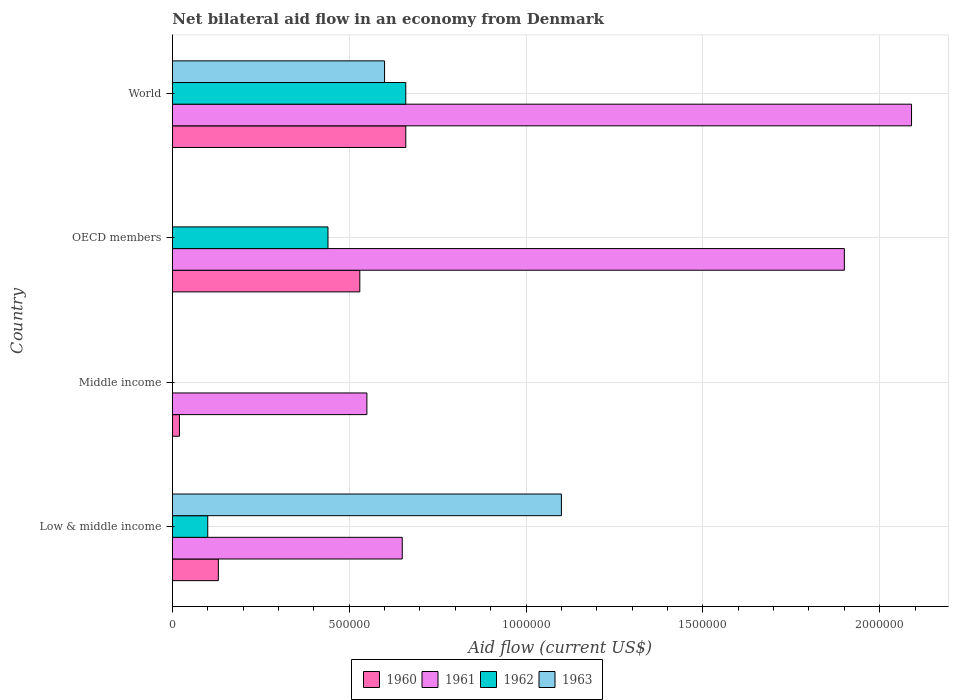Are the number of bars per tick equal to the number of legend labels?
Your answer should be compact. No. Are the number of bars on each tick of the Y-axis equal?
Provide a short and direct response. No. What is the label of the 3rd group of bars from the top?
Your answer should be very brief. Middle income. In how many cases, is the number of bars for a given country not equal to the number of legend labels?
Your answer should be very brief. 2. Across all countries, what is the minimum net bilateral aid flow in 1963?
Your answer should be compact. 0. What is the total net bilateral aid flow in 1963 in the graph?
Give a very brief answer. 1.70e+06. What is the difference between the net bilateral aid flow in 1963 in Middle income and the net bilateral aid flow in 1960 in World?
Give a very brief answer. -6.60e+05. What is the average net bilateral aid flow in 1963 per country?
Provide a succinct answer. 4.25e+05. What is the difference between the net bilateral aid flow in 1962 and net bilateral aid flow in 1961 in World?
Provide a succinct answer. -1.43e+06. In how many countries, is the net bilateral aid flow in 1962 greater than 600000 US$?
Provide a short and direct response. 1. What is the ratio of the net bilateral aid flow in 1960 in Middle income to that in World?
Your answer should be compact. 0.03. Is the difference between the net bilateral aid flow in 1962 in OECD members and World greater than the difference between the net bilateral aid flow in 1961 in OECD members and World?
Offer a terse response. No. What is the difference between the highest and the second highest net bilateral aid flow in 1961?
Keep it short and to the point. 1.90e+05. What is the difference between the highest and the lowest net bilateral aid flow in 1963?
Keep it short and to the point. 1.10e+06. Is the sum of the net bilateral aid flow in 1962 in Low & middle income and OECD members greater than the maximum net bilateral aid flow in 1963 across all countries?
Provide a short and direct response. No. Are all the bars in the graph horizontal?
Keep it short and to the point. Yes. How many countries are there in the graph?
Offer a very short reply. 4. What is the difference between two consecutive major ticks on the X-axis?
Provide a succinct answer. 5.00e+05. Are the values on the major ticks of X-axis written in scientific E-notation?
Provide a succinct answer. No. Does the graph contain any zero values?
Give a very brief answer. Yes. Where does the legend appear in the graph?
Provide a succinct answer. Bottom center. How many legend labels are there?
Make the answer very short. 4. How are the legend labels stacked?
Give a very brief answer. Horizontal. What is the title of the graph?
Your response must be concise. Net bilateral aid flow in an economy from Denmark. What is the label or title of the Y-axis?
Your answer should be compact. Country. What is the Aid flow (current US$) of 1960 in Low & middle income?
Your answer should be very brief. 1.30e+05. What is the Aid flow (current US$) in 1961 in Low & middle income?
Keep it short and to the point. 6.50e+05. What is the Aid flow (current US$) of 1963 in Low & middle income?
Provide a succinct answer. 1.10e+06. What is the Aid flow (current US$) of 1960 in Middle income?
Provide a short and direct response. 2.00e+04. What is the Aid flow (current US$) of 1962 in Middle income?
Make the answer very short. 0. What is the Aid flow (current US$) in 1960 in OECD members?
Your answer should be compact. 5.30e+05. What is the Aid flow (current US$) of 1961 in OECD members?
Offer a terse response. 1.90e+06. What is the Aid flow (current US$) in 1960 in World?
Give a very brief answer. 6.60e+05. What is the Aid flow (current US$) in 1961 in World?
Your answer should be very brief. 2.09e+06. What is the Aid flow (current US$) in 1962 in World?
Provide a short and direct response. 6.60e+05. What is the Aid flow (current US$) in 1963 in World?
Provide a short and direct response. 6.00e+05. Across all countries, what is the maximum Aid flow (current US$) of 1960?
Make the answer very short. 6.60e+05. Across all countries, what is the maximum Aid flow (current US$) in 1961?
Provide a succinct answer. 2.09e+06. Across all countries, what is the maximum Aid flow (current US$) of 1962?
Your response must be concise. 6.60e+05. Across all countries, what is the maximum Aid flow (current US$) in 1963?
Give a very brief answer. 1.10e+06. Across all countries, what is the minimum Aid flow (current US$) in 1961?
Offer a terse response. 5.50e+05. Across all countries, what is the minimum Aid flow (current US$) in 1963?
Your answer should be compact. 0. What is the total Aid flow (current US$) of 1960 in the graph?
Provide a short and direct response. 1.34e+06. What is the total Aid flow (current US$) of 1961 in the graph?
Offer a terse response. 5.19e+06. What is the total Aid flow (current US$) in 1962 in the graph?
Your answer should be very brief. 1.20e+06. What is the total Aid flow (current US$) in 1963 in the graph?
Make the answer very short. 1.70e+06. What is the difference between the Aid flow (current US$) in 1960 in Low & middle income and that in OECD members?
Offer a terse response. -4.00e+05. What is the difference between the Aid flow (current US$) in 1961 in Low & middle income and that in OECD members?
Provide a short and direct response. -1.25e+06. What is the difference between the Aid flow (current US$) of 1960 in Low & middle income and that in World?
Your answer should be compact. -5.30e+05. What is the difference between the Aid flow (current US$) in 1961 in Low & middle income and that in World?
Give a very brief answer. -1.44e+06. What is the difference between the Aid flow (current US$) in 1962 in Low & middle income and that in World?
Give a very brief answer. -5.60e+05. What is the difference between the Aid flow (current US$) in 1960 in Middle income and that in OECD members?
Ensure brevity in your answer.  -5.10e+05. What is the difference between the Aid flow (current US$) of 1961 in Middle income and that in OECD members?
Offer a very short reply. -1.35e+06. What is the difference between the Aid flow (current US$) in 1960 in Middle income and that in World?
Your answer should be very brief. -6.40e+05. What is the difference between the Aid flow (current US$) of 1961 in Middle income and that in World?
Provide a short and direct response. -1.54e+06. What is the difference between the Aid flow (current US$) in 1960 in OECD members and that in World?
Ensure brevity in your answer.  -1.30e+05. What is the difference between the Aid flow (current US$) in 1962 in OECD members and that in World?
Make the answer very short. -2.20e+05. What is the difference between the Aid flow (current US$) in 1960 in Low & middle income and the Aid flow (current US$) in 1961 in Middle income?
Ensure brevity in your answer.  -4.20e+05. What is the difference between the Aid flow (current US$) in 1960 in Low & middle income and the Aid flow (current US$) in 1961 in OECD members?
Offer a terse response. -1.77e+06. What is the difference between the Aid flow (current US$) of 1960 in Low & middle income and the Aid flow (current US$) of 1962 in OECD members?
Make the answer very short. -3.10e+05. What is the difference between the Aid flow (current US$) of 1961 in Low & middle income and the Aid flow (current US$) of 1962 in OECD members?
Offer a terse response. 2.10e+05. What is the difference between the Aid flow (current US$) of 1960 in Low & middle income and the Aid flow (current US$) of 1961 in World?
Provide a succinct answer. -1.96e+06. What is the difference between the Aid flow (current US$) in 1960 in Low & middle income and the Aid flow (current US$) in 1962 in World?
Offer a very short reply. -5.30e+05. What is the difference between the Aid flow (current US$) of 1960 in Low & middle income and the Aid flow (current US$) of 1963 in World?
Provide a short and direct response. -4.70e+05. What is the difference between the Aid flow (current US$) of 1961 in Low & middle income and the Aid flow (current US$) of 1962 in World?
Provide a succinct answer. -10000. What is the difference between the Aid flow (current US$) in 1962 in Low & middle income and the Aid flow (current US$) in 1963 in World?
Your answer should be compact. -5.00e+05. What is the difference between the Aid flow (current US$) of 1960 in Middle income and the Aid flow (current US$) of 1961 in OECD members?
Provide a short and direct response. -1.88e+06. What is the difference between the Aid flow (current US$) of 1960 in Middle income and the Aid flow (current US$) of 1962 in OECD members?
Make the answer very short. -4.20e+05. What is the difference between the Aid flow (current US$) of 1961 in Middle income and the Aid flow (current US$) of 1962 in OECD members?
Offer a very short reply. 1.10e+05. What is the difference between the Aid flow (current US$) of 1960 in Middle income and the Aid flow (current US$) of 1961 in World?
Provide a succinct answer. -2.07e+06. What is the difference between the Aid flow (current US$) in 1960 in Middle income and the Aid flow (current US$) in 1962 in World?
Make the answer very short. -6.40e+05. What is the difference between the Aid flow (current US$) in 1960 in Middle income and the Aid flow (current US$) in 1963 in World?
Your answer should be compact. -5.80e+05. What is the difference between the Aid flow (current US$) in 1961 in Middle income and the Aid flow (current US$) in 1963 in World?
Your answer should be very brief. -5.00e+04. What is the difference between the Aid flow (current US$) of 1960 in OECD members and the Aid flow (current US$) of 1961 in World?
Your response must be concise. -1.56e+06. What is the difference between the Aid flow (current US$) of 1960 in OECD members and the Aid flow (current US$) of 1962 in World?
Give a very brief answer. -1.30e+05. What is the difference between the Aid flow (current US$) in 1960 in OECD members and the Aid flow (current US$) in 1963 in World?
Your answer should be compact. -7.00e+04. What is the difference between the Aid flow (current US$) of 1961 in OECD members and the Aid flow (current US$) of 1962 in World?
Offer a terse response. 1.24e+06. What is the difference between the Aid flow (current US$) in 1961 in OECD members and the Aid flow (current US$) in 1963 in World?
Ensure brevity in your answer.  1.30e+06. What is the difference between the Aid flow (current US$) of 1962 in OECD members and the Aid flow (current US$) of 1963 in World?
Offer a very short reply. -1.60e+05. What is the average Aid flow (current US$) in 1960 per country?
Keep it short and to the point. 3.35e+05. What is the average Aid flow (current US$) of 1961 per country?
Your answer should be very brief. 1.30e+06. What is the average Aid flow (current US$) in 1962 per country?
Your answer should be very brief. 3.00e+05. What is the average Aid flow (current US$) in 1963 per country?
Ensure brevity in your answer.  4.25e+05. What is the difference between the Aid flow (current US$) in 1960 and Aid flow (current US$) in 1961 in Low & middle income?
Make the answer very short. -5.20e+05. What is the difference between the Aid flow (current US$) of 1960 and Aid flow (current US$) of 1963 in Low & middle income?
Your response must be concise. -9.70e+05. What is the difference between the Aid flow (current US$) of 1961 and Aid flow (current US$) of 1963 in Low & middle income?
Provide a short and direct response. -4.50e+05. What is the difference between the Aid flow (current US$) of 1960 and Aid flow (current US$) of 1961 in Middle income?
Your answer should be compact. -5.30e+05. What is the difference between the Aid flow (current US$) of 1960 and Aid flow (current US$) of 1961 in OECD members?
Give a very brief answer. -1.37e+06. What is the difference between the Aid flow (current US$) of 1961 and Aid flow (current US$) of 1962 in OECD members?
Provide a short and direct response. 1.46e+06. What is the difference between the Aid flow (current US$) of 1960 and Aid flow (current US$) of 1961 in World?
Make the answer very short. -1.43e+06. What is the difference between the Aid flow (current US$) of 1960 and Aid flow (current US$) of 1962 in World?
Offer a terse response. 0. What is the difference between the Aid flow (current US$) of 1960 and Aid flow (current US$) of 1963 in World?
Provide a short and direct response. 6.00e+04. What is the difference between the Aid flow (current US$) in 1961 and Aid flow (current US$) in 1962 in World?
Offer a very short reply. 1.43e+06. What is the difference between the Aid flow (current US$) of 1961 and Aid flow (current US$) of 1963 in World?
Your answer should be very brief. 1.49e+06. What is the difference between the Aid flow (current US$) in 1962 and Aid flow (current US$) in 1963 in World?
Your answer should be compact. 6.00e+04. What is the ratio of the Aid flow (current US$) of 1960 in Low & middle income to that in Middle income?
Offer a very short reply. 6.5. What is the ratio of the Aid flow (current US$) in 1961 in Low & middle income to that in Middle income?
Your answer should be compact. 1.18. What is the ratio of the Aid flow (current US$) in 1960 in Low & middle income to that in OECD members?
Your answer should be very brief. 0.25. What is the ratio of the Aid flow (current US$) in 1961 in Low & middle income to that in OECD members?
Offer a very short reply. 0.34. What is the ratio of the Aid flow (current US$) of 1962 in Low & middle income to that in OECD members?
Keep it short and to the point. 0.23. What is the ratio of the Aid flow (current US$) of 1960 in Low & middle income to that in World?
Offer a terse response. 0.2. What is the ratio of the Aid flow (current US$) in 1961 in Low & middle income to that in World?
Ensure brevity in your answer.  0.31. What is the ratio of the Aid flow (current US$) of 1962 in Low & middle income to that in World?
Keep it short and to the point. 0.15. What is the ratio of the Aid flow (current US$) in 1963 in Low & middle income to that in World?
Your answer should be very brief. 1.83. What is the ratio of the Aid flow (current US$) in 1960 in Middle income to that in OECD members?
Make the answer very short. 0.04. What is the ratio of the Aid flow (current US$) of 1961 in Middle income to that in OECD members?
Your response must be concise. 0.29. What is the ratio of the Aid flow (current US$) of 1960 in Middle income to that in World?
Keep it short and to the point. 0.03. What is the ratio of the Aid flow (current US$) in 1961 in Middle income to that in World?
Give a very brief answer. 0.26. What is the ratio of the Aid flow (current US$) of 1960 in OECD members to that in World?
Ensure brevity in your answer.  0.8. What is the difference between the highest and the second highest Aid flow (current US$) in 1962?
Your answer should be very brief. 2.20e+05. What is the difference between the highest and the lowest Aid flow (current US$) in 1960?
Your response must be concise. 6.40e+05. What is the difference between the highest and the lowest Aid flow (current US$) of 1961?
Provide a succinct answer. 1.54e+06. What is the difference between the highest and the lowest Aid flow (current US$) of 1963?
Offer a very short reply. 1.10e+06. 